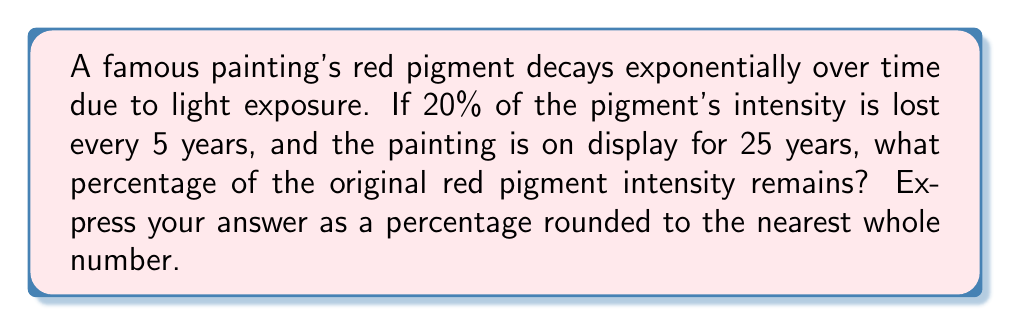Show me your answer to this math problem. Let's approach this step-by-step:

1) First, we need to determine the rate of decay per 5-year period:
   20% loss means 80% remains after each 5-year period.
   
2) We can express this as a decimal: 0.80

3) Now, we need to determine how many 5-year periods are in 25 years:
   $25 \div 5 = 5$ periods

4) The exponential decay formula is:
   $A = P(1-r)^n$
   Where:
   $A$ = final amount
   $P$ = initial amount (100% in this case)
   $r$ = decay rate (0.20 or 20%)
   $n$ = number of periods (5)

5) Plugging in our values:
   $A = 100(1-0.20)^5 = 100(0.80)^5$

6) Calculate:
   $A = 100 \times 0.32768 = 32.768\%$

7) Rounding to the nearest whole number:
   $32.768\% \approx 33\%$
Answer: 33% 